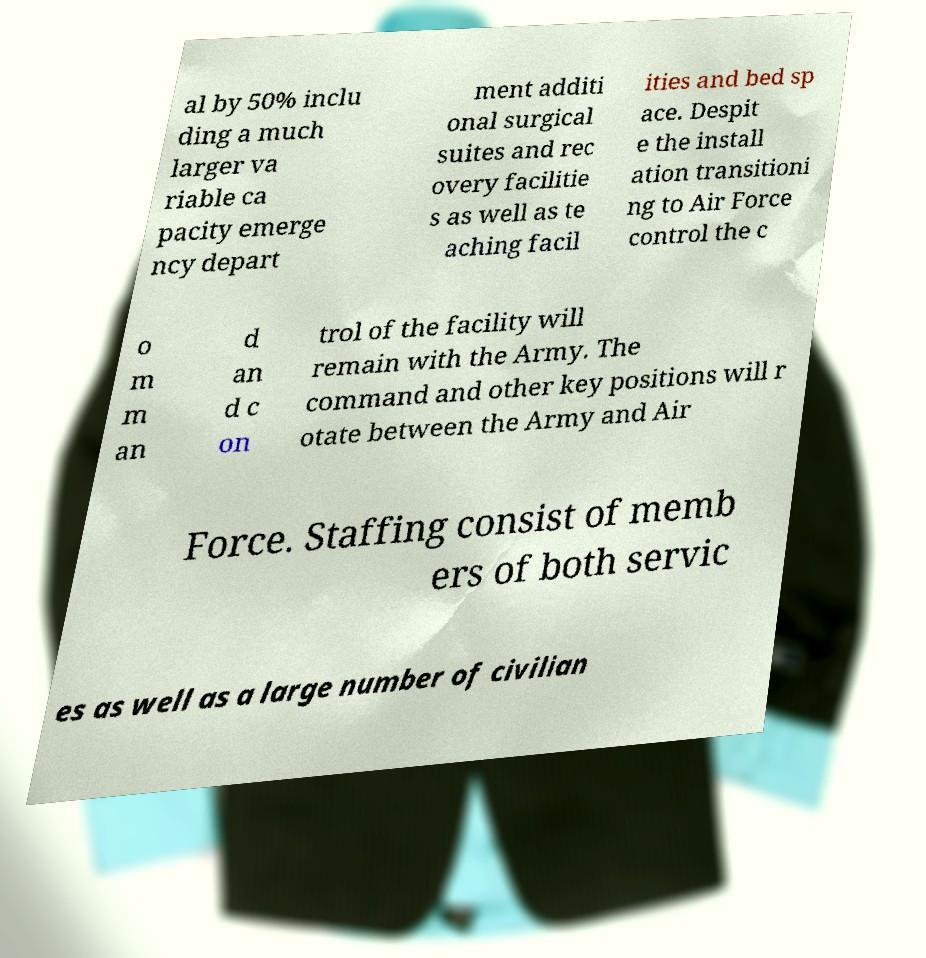Please read and relay the text visible in this image. What does it say? al by 50% inclu ding a much larger va riable ca pacity emerge ncy depart ment additi onal surgical suites and rec overy facilitie s as well as te aching facil ities and bed sp ace. Despit e the install ation transitioni ng to Air Force control the c o m m an d an d c on trol of the facility will remain with the Army. The command and other key positions will r otate between the Army and Air Force. Staffing consist of memb ers of both servic es as well as a large number of civilian 